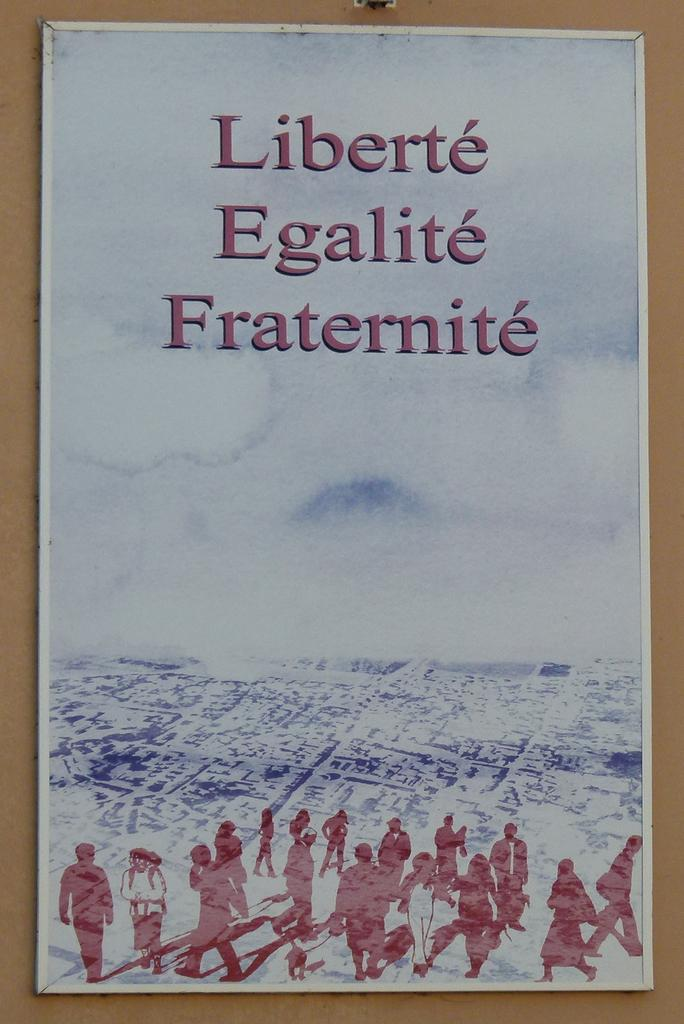<image>
Relay a brief, clear account of the picture shown. A drawing of people all in red with a pale blue sky behind them and the words, liberte, egalite, and fraternite above them. 